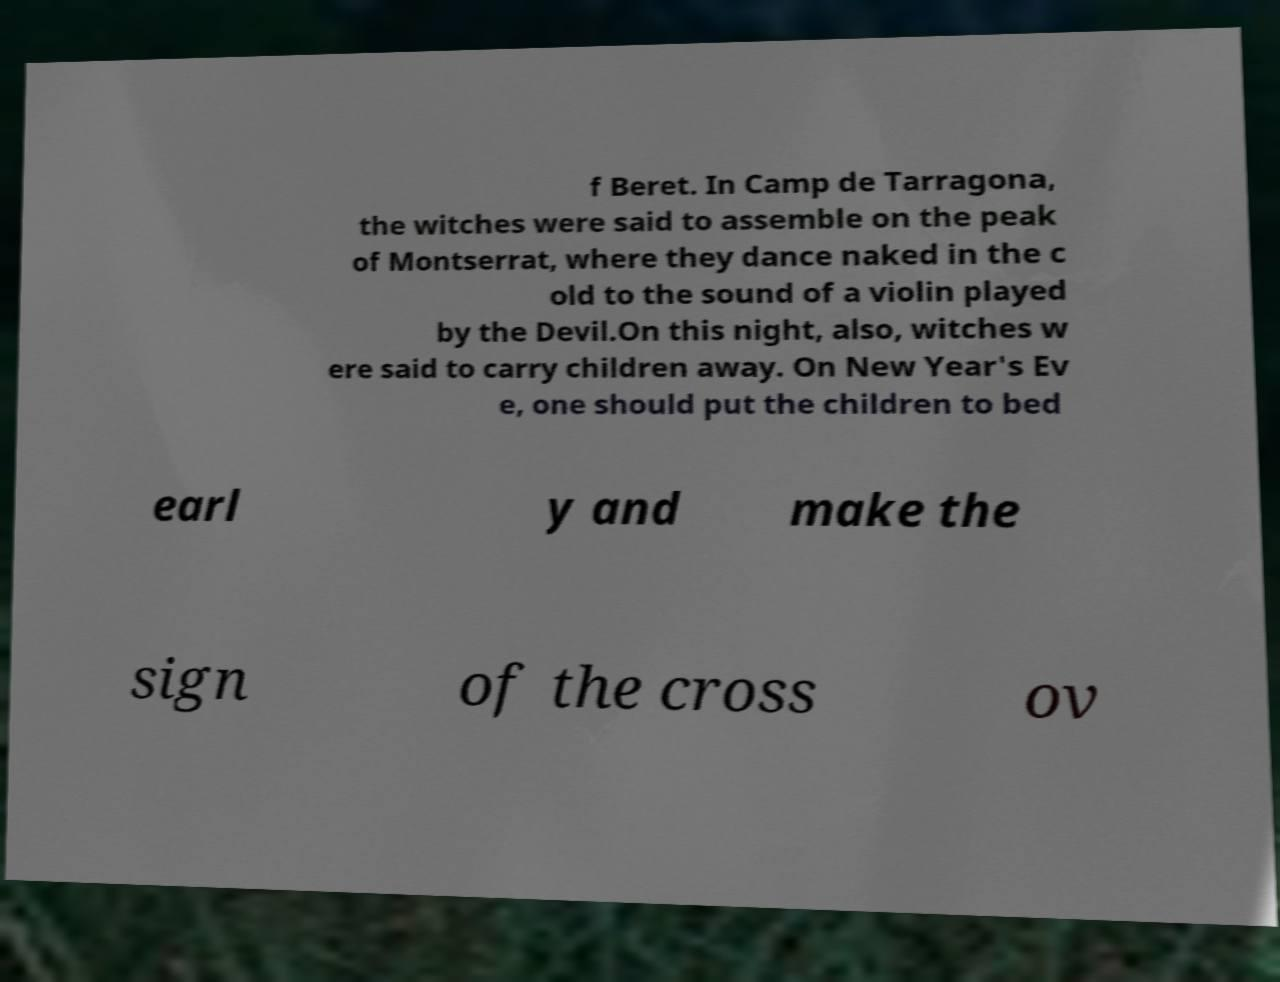There's text embedded in this image that I need extracted. Can you transcribe it verbatim? f Beret. In Camp de Tarragona, the witches were said to assemble on the peak of Montserrat, where they dance naked in the c old to the sound of a violin played by the Devil.On this night, also, witches w ere said to carry children away. On New Year's Ev e, one should put the children to bed earl y and make the sign of the cross ov 